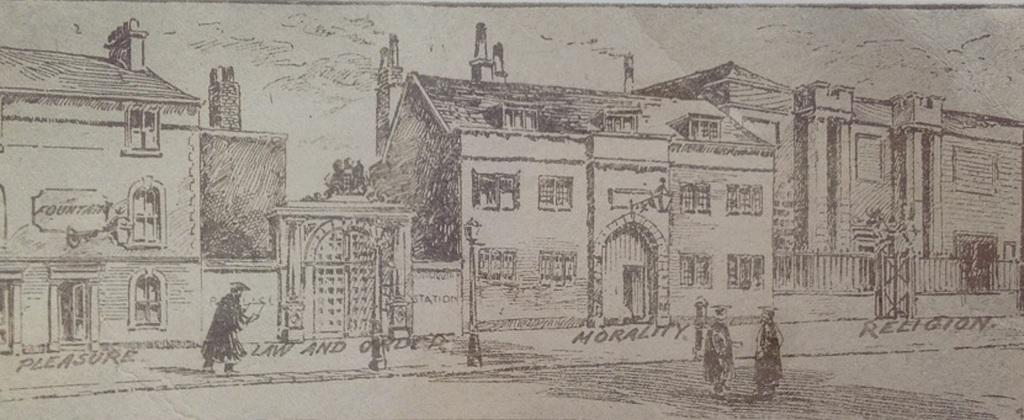What type of structures are depicted in the drawing? The drawing contains buildings. What natural features are present in the drawing? The drawing contains mountains. Are there any living beings depicted in the drawing? Yes, the drawing contains people. How many sheep are visible in the drawing? There are no sheep present in the drawing; it contains buildings, mountains, and people. Is there a stamp on the drawing? There is no stamp present in the drawing. 